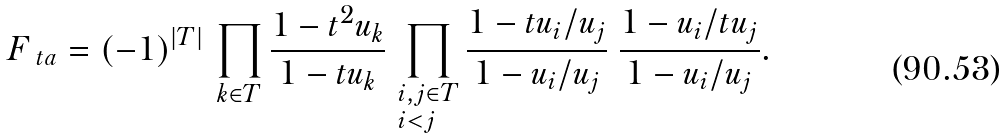Convert formula to latex. <formula><loc_0><loc_0><loc_500><loc_500>F _ { \ t a } = ( - 1 ) ^ { | T | } \, \prod _ { k \in T } \frac { 1 - t ^ { 2 } u _ { k } } { 1 - t u _ { k } } \, \prod _ { \begin{subarray} { c } i , j \in T \\ i < j \end{subarray} } \frac { 1 - t u _ { i } / u _ { j } } { 1 - u _ { i } / u _ { j } } \ \frac { 1 - u _ { i } / t u _ { j } } { 1 - u _ { i } / u _ { j } } .</formula> 